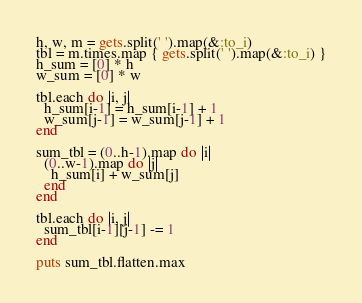Convert code to text. <code><loc_0><loc_0><loc_500><loc_500><_Ruby_>h, w, m = gets.split(' ').map(&:to_i)
tbl = m.times.map { gets.split(' ').map(&:to_i) }
h_sum = [0] * h
w_sum = [0] * w

tbl.each do |i, j|
  h_sum[i-1] = h_sum[i-1] + 1
  w_sum[j-1] = w_sum[j-1] + 1
end

sum_tbl = (0..h-1).map do |i|
  (0..w-1).map do |j|
    h_sum[i] + w_sum[j]
  end
end

tbl.each do |i, j|
  sum_tbl[i-1][j-1] -= 1
end

puts sum_tbl.flatten.max

</code> 